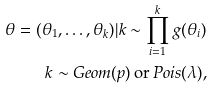<formula> <loc_0><loc_0><loc_500><loc_500>\theta = ( \theta _ { 1 } , \dots , \theta _ { k } ) | k \sim \prod _ { i = 1 } ^ { k } g ( \theta _ { i } ) \\ k \sim G e o m ( p ) \, \text {or} \, P o i s ( \lambda ) ,</formula> 